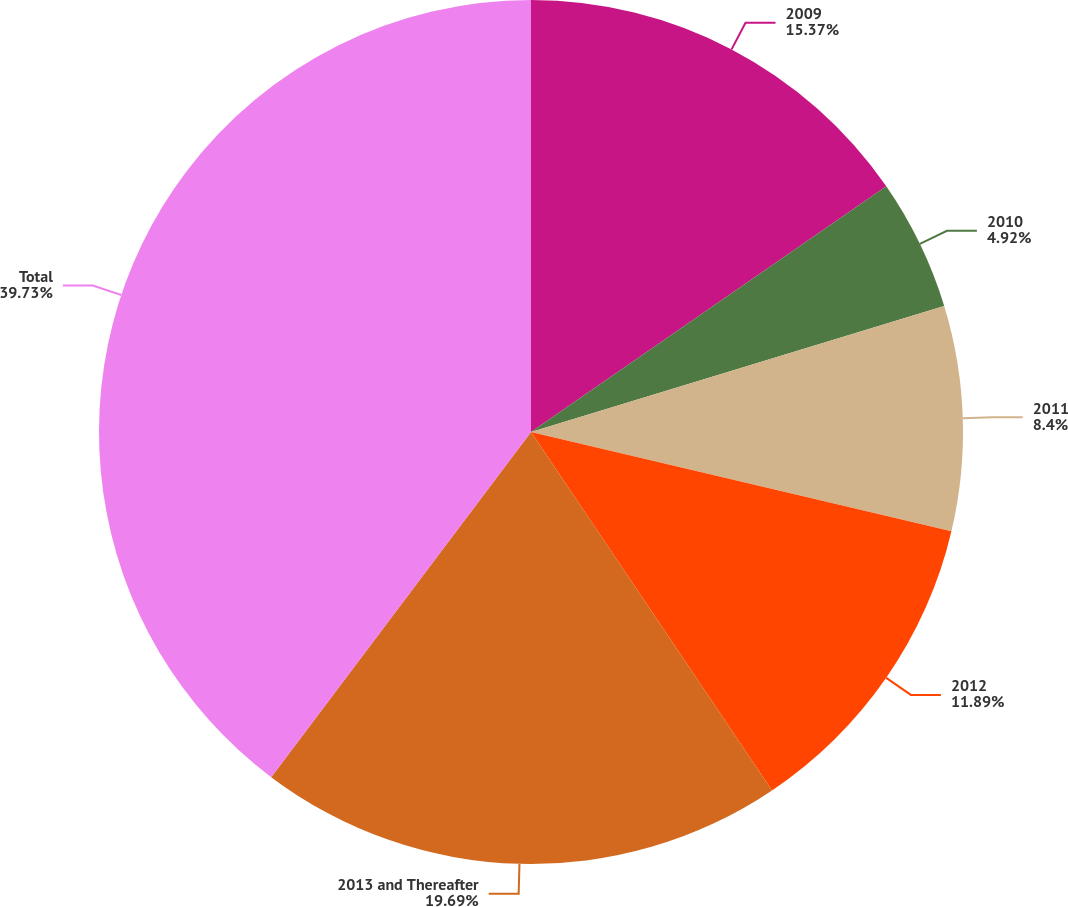Convert chart. <chart><loc_0><loc_0><loc_500><loc_500><pie_chart><fcel>2009<fcel>2010<fcel>2011<fcel>2012<fcel>2013 and Thereafter<fcel>Total<nl><fcel>15.37%<fcel>4.92%<fcel>8.4%<fcel>11.89%<fcel>19.69%<fcel>39.73%<nl></chart> 